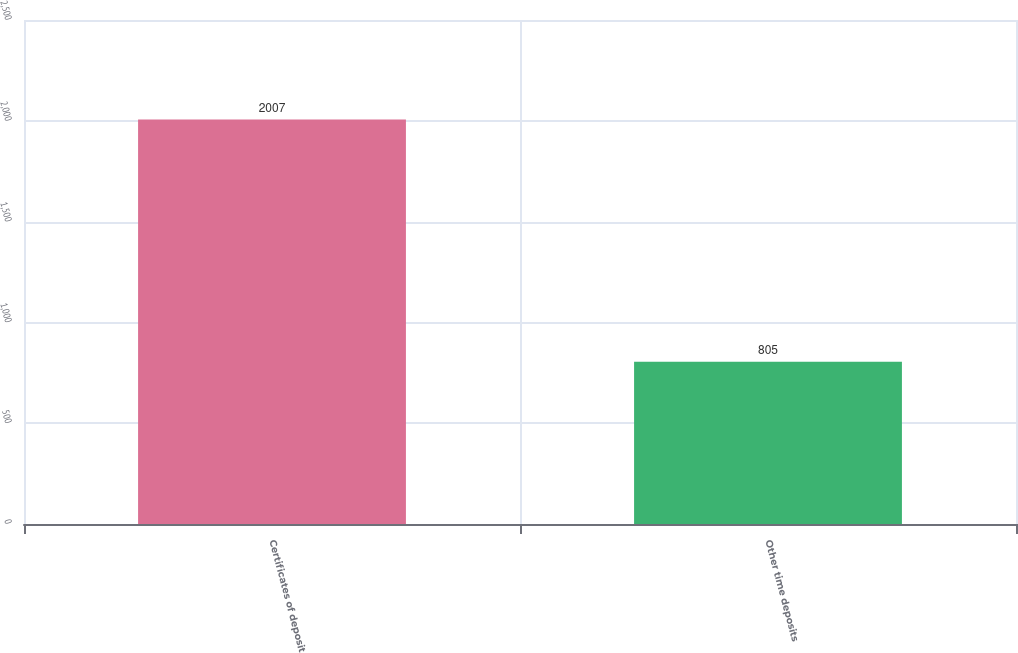Convert chart. <chart><loc_0><loc_0><loc_500><loc_500><bar_chart><fcel>Certificates of deposit<fcel>Other time deposits<nl><fcel>2007<fcel>805<nl></chart> 